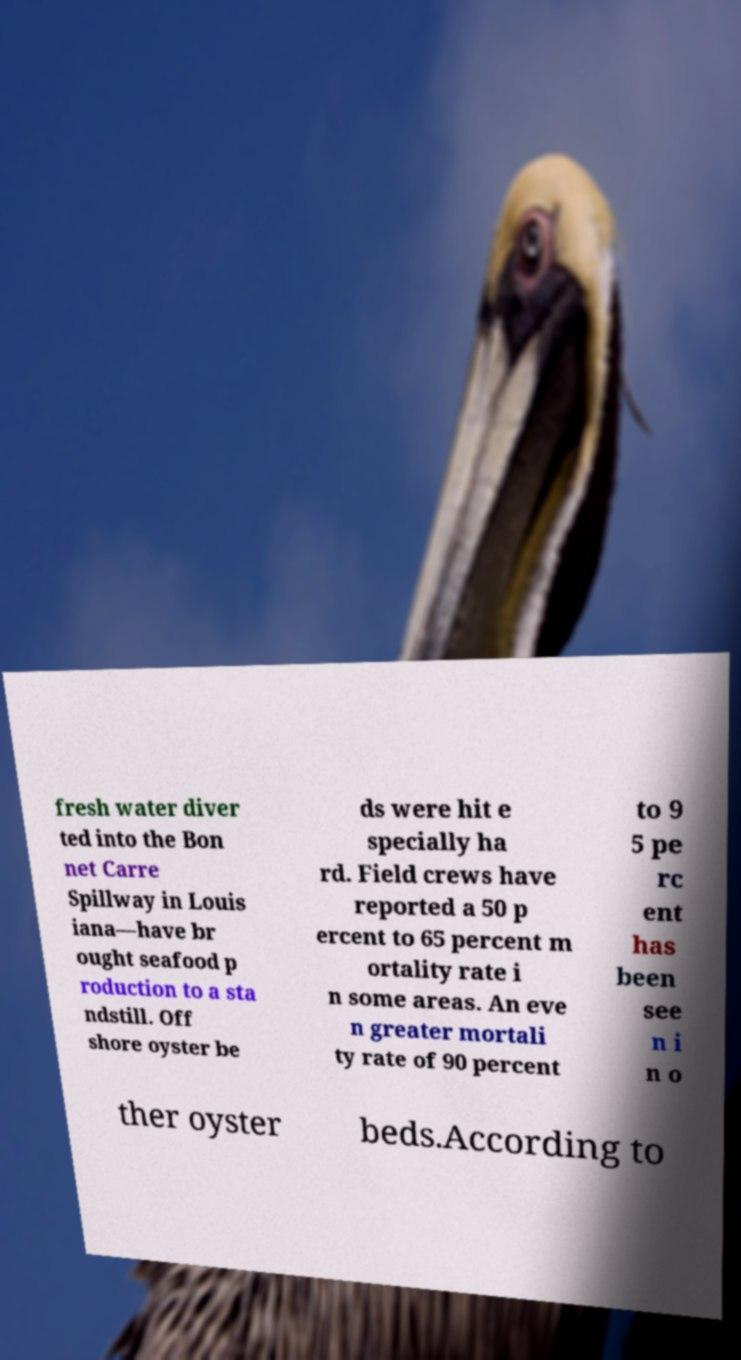There's text embedded in this image that I need extracted. Can you transcribe it verbatim? fresh water diver ted into the Bon net Carre Spillway in Louis iana—have br ought seafood p roduction to a sta ndstill. Off shore oyster be ds were hit e specially ha rd. Field crews have reported a 50 p ercent to 65 percent m ortality rate i n some areas. An eve n greater mortali ty rate of 90 percent to 9 5 pe rc ent has been see n i n o ther oyster beds.According to 